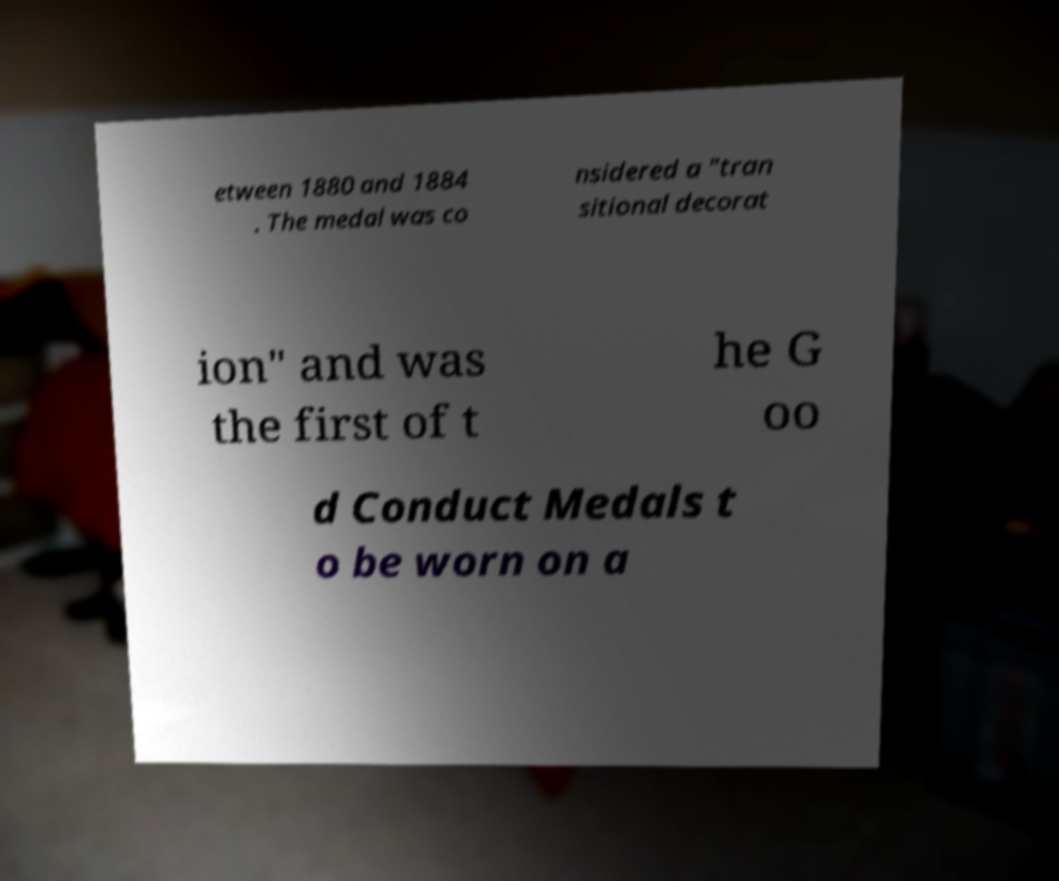I need the written content from this picture converted into text. Can you do that? etween 1880 and 1884 . The medal was co nsidered a "tran sitional decorat ion" and was the first of t he G oo d Conduct Medals t o be worn on a 